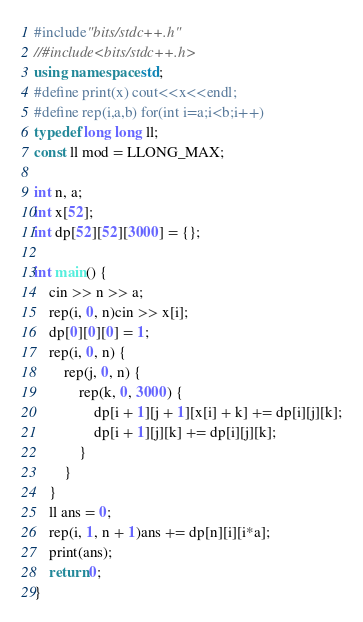<code> <loc_0><loc_0><loc_500><loc_500><_C++_>#include"bits/stdc++.h"
//#include<bits/stdc++.h>
using namespace std;
#define print(x) cout<<x<<endl;
#define rep(i,a,b) for(int i=a;i<b;i++)
typedef long long ll;
const ll mod = LLONG_MAX;

int n, a;
int x[52];
int dp[52][52][3000] = {};

int main() {
	cin >> n >> a;
	rep(i, 0, n)cin >> x[i];
	dp[0][0][0] = 1;
	rep(i, 0, n) {
		rep(j, 0, n) {
			rep(k, 0, 3000) {
				dp[i + 1][j + 1][x[i] + k] += dp[i][j][k];
				dp[i + 1][j][k] += dp[i][j][k];
			}
		}
	}
	ll ans = 0;
	rep(i, 1, n + 1)ans += dp[n][i][i*a];
	print(ans);
	return 0;
}</code> 